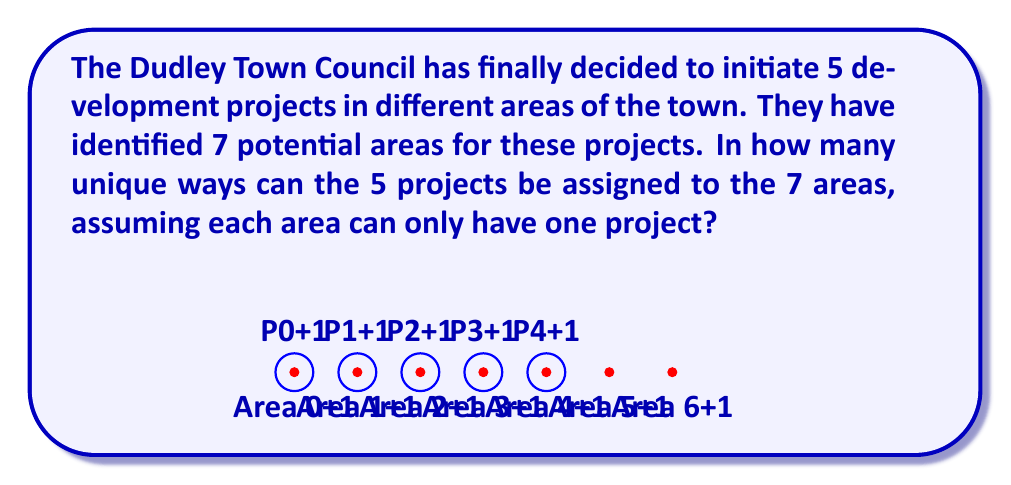Show me your answer to this math problem. Let's approach this step-by-step:

1) This problem is essentially asking for the number of ways to choose 5 areas out of 7 and then arrange the 5 projects in these chosen areas.

2) First, we need to choose 5 areas out of 7. This is a combination problem, denoted as $\binom{7}{5}$ or $C(7,5)$.

   $\binom{7}{5} = \frac{7!}{5!(7-5)!} = \frac{7!}{5!2!}$

3) After choosing the 5 areas, we need to arrange the 5 projects in these areas. This is a permutation of 5 objects, which is simply 5!.

4) By the multiplication principle, the total number of ways to assign the projects is:

   $\binom{7}{5} \cdot 5!$

5) Let's calculate this:
   
   $\binom{7}{5} \cdot 5! = \frac{7!}{5!2!} \cdot 5! = \frac{7!}{2!} = \frac{7 \cdot 6 \cdot 5!}{2}$

6) Simplifying:
   
   $\frac{7 \cdot 6 \cdot 5!}{2} = 21 \cdot 5! = 21 \cdot 120 = 2520$

Therefore, there are 2520 unique ways to assign the 5 projects to the 7 areas of Dudley.
Answer: 2520 